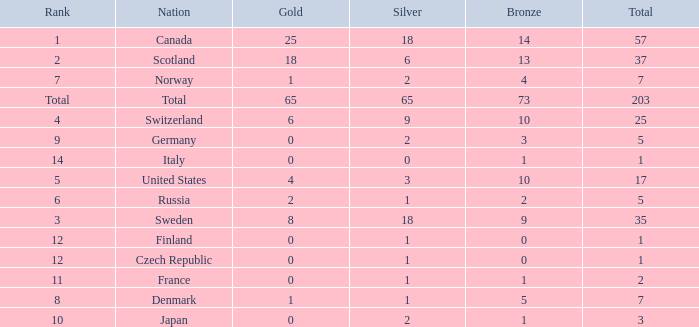What is the number of bronze medals when the total is greater than 1, more than 2 silver medals are won, and the rank is 2? 13.0. 